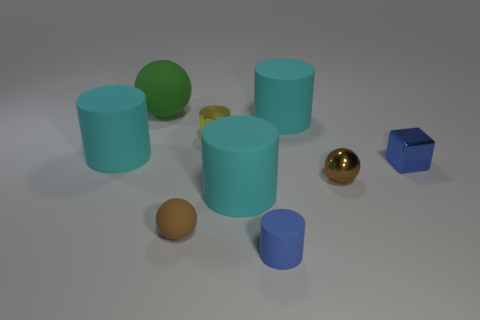Subtract all rubber cylinders. How many cylinders are left? 1 Add 1 red shiny spheres. How many objects exist? 10 Subtract all green blocks. How many brown balls are left? 2 Subtract 1 cylinders. How many cylinders are left? 4 Subtract all green balls. How many balls are left? 2 Subtract all cubes. How many objects are left? 8 Add 1 small blue shiny cubes. How many small blue shiny cubes are left? 2 Add 4 tiny gray matte cylinders. How many tiny gray matte cylinders exist? 4 Subtract 0 blue balls. How many objects are left? 9 Subtract all blue balls. Subtract all blue cubes. How many balls are left? 3 